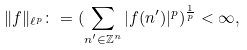Convert formula to latex. <formula><loc_0><loc_0><loc_500><loc_500>\| f \| _ { \ell ^ { p } } \colon = ( \sum _ { n ^ { \prime } \in \mathbb { Z } ^ { n } } | f ( n ^ { \prime } ) | ^ { p } ) ^ { \frac { 1 } { p } } < \infty ,</formula> 